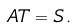Convert formula to latex. <formula><loc_0><loc_0><loc_500><loc_500>\ A T = S \, .</formula> 